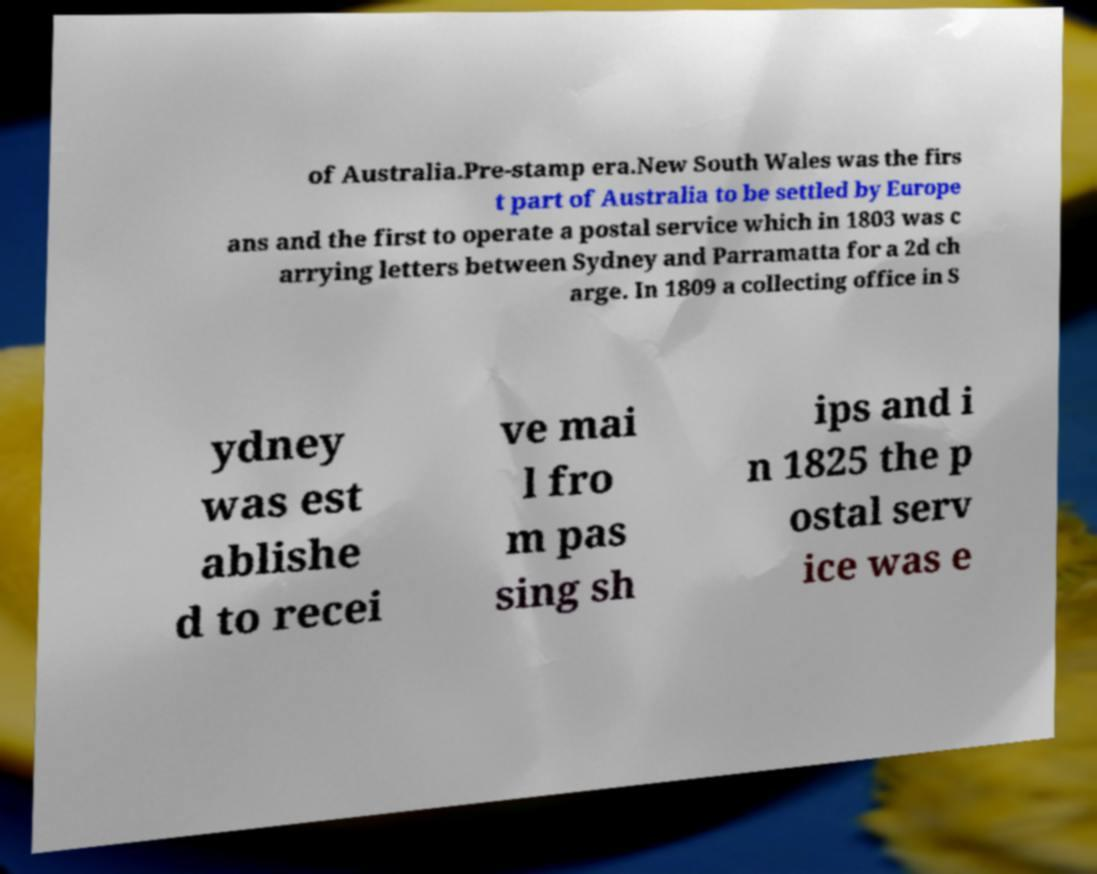Could you extract and type out the text from this image? of Australia.Pre-stamp era.New South Wales was the firs t part of Australia to be settled by Europe ans and the first to operate a postal service which in 1803 was c arrying letters between Sydney and Parramatta for a 2d ch arge. In 1809 a collecting office in S ydney was est ablishe d to recei ve mai l fro m pas sing sh ips and i n 1825 the p ostal serv ice was e 